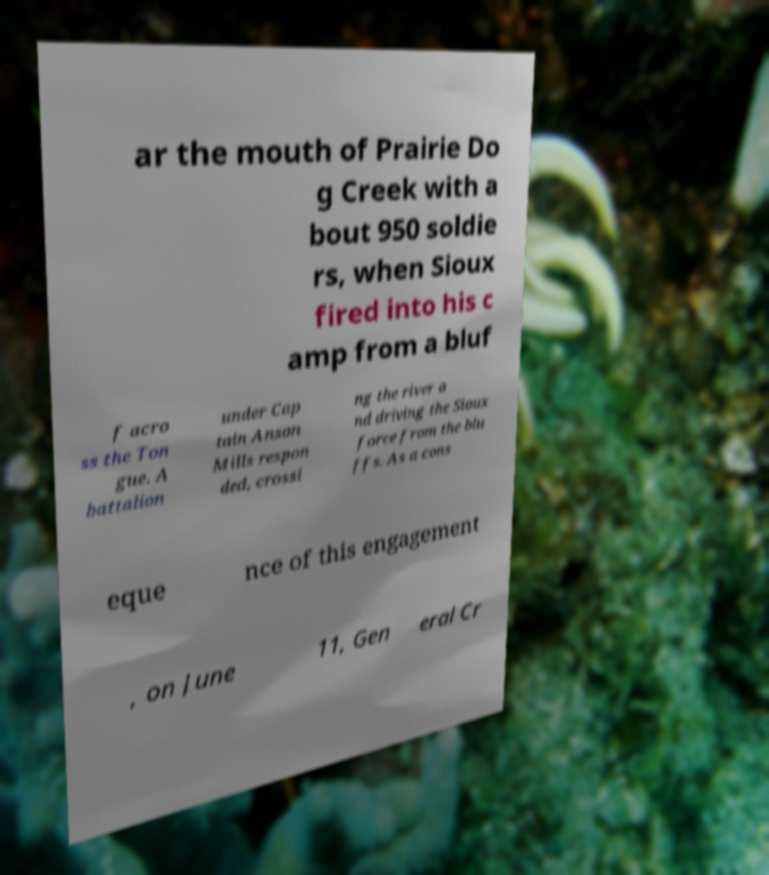What messages or text are displayed in this image? I need them in a readable, typed format. ar the mouth of Prairie Do g Creek with a bout 950 soldie rs, when Sioux fired into his c amp from a bluf f acro ss the Ton gue. A battalion under Cap tain Anson Mills respon ded, crossi ng the river a nd driving the Sioux force from the blu ffs. As a cons eque nce of this engagement , on June 11, Gen eral Cr 